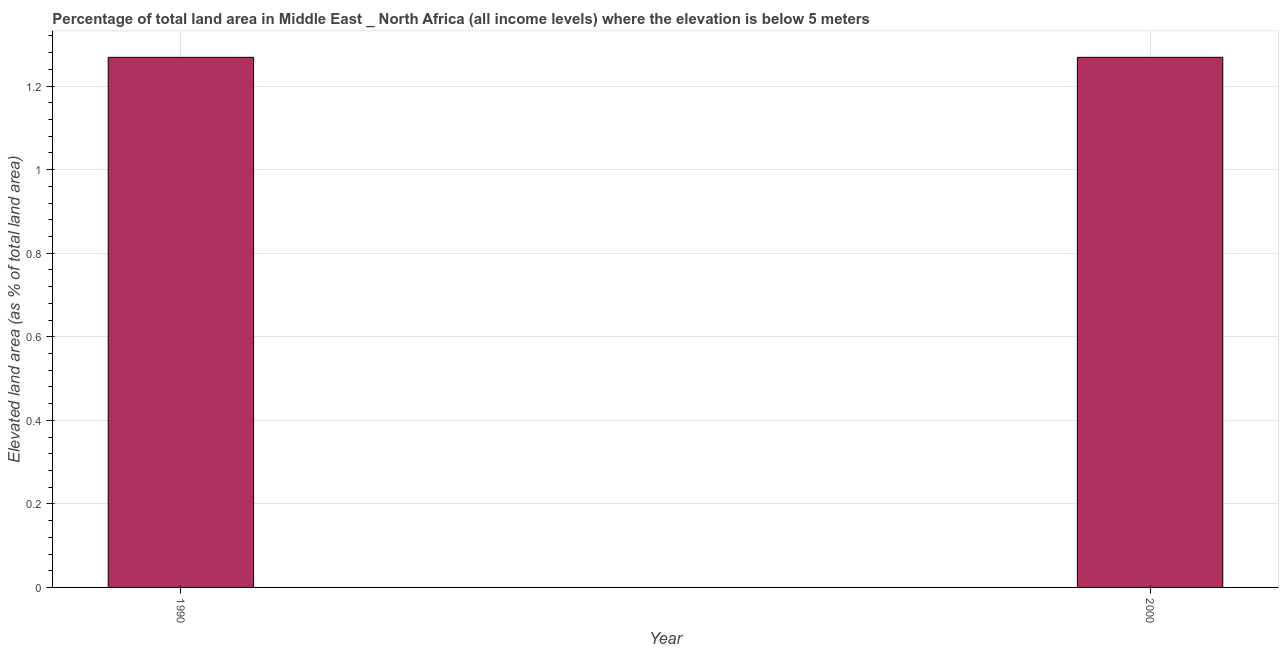What is the title of the graph?
Your response must be concise. Percentage of total land area in Middle East _ North Africa (all income levels) where the elevation is below 5 meters. What is the label or title of the Y-axis?
Keep it short and to the point. Elevated land area (as % of total land area). What is the total elevated land area in 1990?
Make the answer very short. 1.27. Across all years, what is the maximum total elevated land area?
Provide a succinct answer. 1.27. Across all years, what is the minimum total elevated land area?
Your response must be concise. 1.27. What is the sum of the total elevated land area?
Keep it short and to the point. 2.54. What is the average total elevated land area per year?
Offer a very short reply. 1.27. What is the median total elevated land area?
Provide a short and direct response. 1.27. Do a majority of the years between 1990 and 2000 (inclusive) have total elevated land area greater than 0.08 %?
Keep it short and to the point. Yes. In how many years, is the total elevated land area greater than the average total elevated land area taken over all years?
Provide a succinct answer. 1. How many bars are there?
Your answer should be compact. 2. Are all the bars in the graph horizontal?
Your response must be concise. No. What is the Elevated land area (as % of total land area) of 1990?
Offer a very short reply. 1.27. What is the Elevated land area (as % of total land area) of 2000?
Provide a short and direct response. 1.27. What is the difference between the Elevated land area (as % of total land area) in 1990 and 2000?
Your answer should be very brief. -7e-5. 